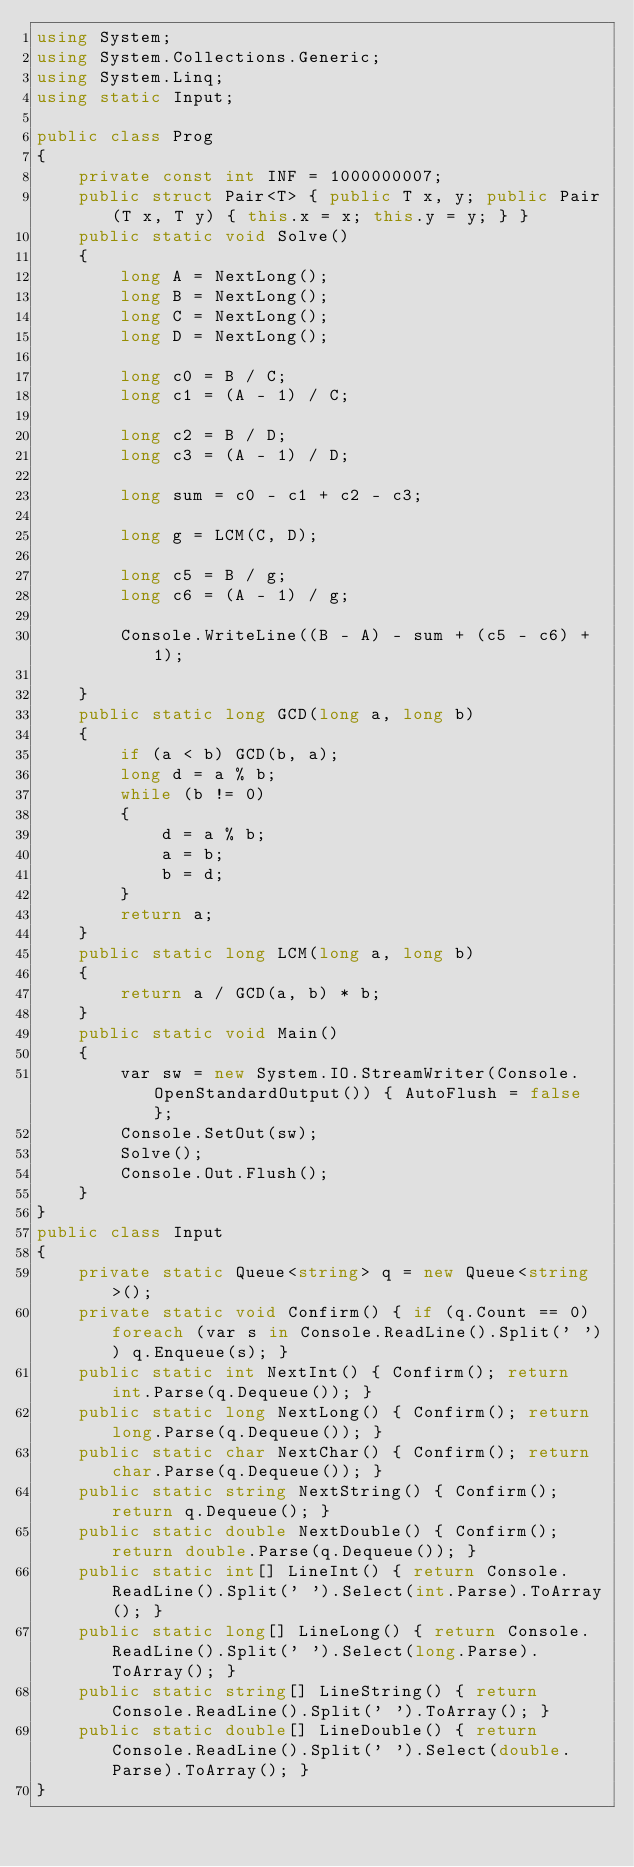Convert code to text. <code><loc_0><loc_0><loc_500><loc_500><_C#_>using System;
using System.Collections.Generic;
using System.Linq;
using static Input;

public class Prog
{
    private const int INF = 1000000007;
    public struct Pair<T> { public T x, y; public Pair(T x, T y) { this.x = x; this.y = y; } }
    public static void Solve()
    {
        long A = NextLong();
        long B = NextLong();
        long C = NextLong();
        long D = NextLong();

        long c0 = B / C;
        long c1 = (A - 1) / C;

        long c2 = B / D;
        long c3 = (A - 1) / D;

        long sum = c0 - c1 + c2 - c3;

        long g = LCM(C, D);

        long c5 = B / g;
        long c6 = (A - 1) / g;

        Console.WriteLine((B - A) - sum + (c5 - c6) + 1);

    }
    public static long GCD(long a, long b)
    {
        if (a < b) GCD(b, a);
        long d = a % b;
        while (b != 0)
        {
            d = a % b;
            a = b;
            b = d;
        }
        return a;
    }
    public static long LCM(long a, long b)
    {
        return a / GCD(a, b) * b;
    }
    public static void Main()
    {
        var sw = new System.IO.StreamWriter(Console.OpenStandardOutput()) { AutoFlush = false };
        Console.SetOut(sw);
        Solve();
        Console.Out.Flush();
    }
}
public class Input
{
    private static Queue<string> q = new Queue<string>();
    private static void Confirm() { if (q.Count == 0) foreach (var s in Console.ReadLine().Split(' ')) q.Enqueue(s); }
    public static int NextInt() { Confirm(); return int.Parse(q.Dequeue()); }
    public static long NextLong() { Confirm(); return long.Parse(q.Dequeue()); }
    public static char NextChar() { Confirm(); return char.Parse(q.Dequeue()); }
    public static string NextString() { Confirm(); return q.Dequeue(); }
    public static double NextDouble() { Confirm(); return double.Parse(q.Dequeue()); }
    public static int[] LineInt() { return Console.ReadLine().Split(' ').Select(int.Parse).ToArray(); }
    public static long[] LineLong() { return Console.ReadLine().Split(' ').Select(long.Parse).ToArray(); }
    public static string[] LineString() { return Console.ReadLine().Split(' ').ToArray(); }
    public static double[] LineDouble() { return Console.ReadLine().Split(' ').Select(double.Parse).ToArray(); }
}
</code> 